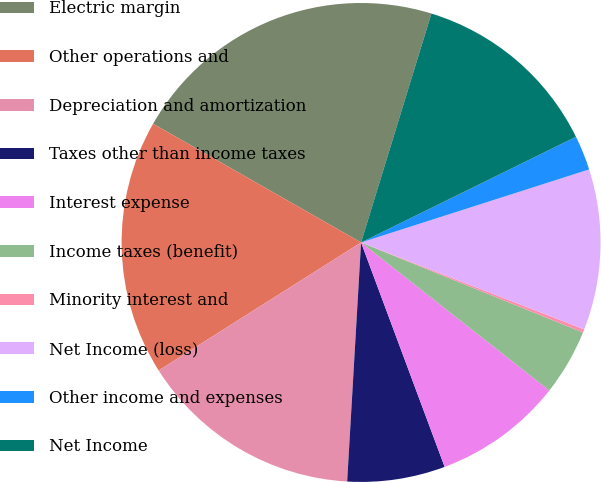Convert chart. <chart><loc_0><loc_0><loc_500><loc_500><pie_chart><fcel>Electric margin<fcel>Other operations and<fcel>Depreciation and amortization<fcel>Taxes other than income taxes<fcel>Interest expense<fcel>Income taxes (benefit)<fcel>Minority interest and<fcel>Net Income (loss)<fcel>Other income and expenses<fcel>Net Income<nl><fcel>21.49%<fcel>17.23%<fcel>15.1%<fcel>6.6%<fcel>8.72%<fcel>4.47%<fcel>0.22%<fcel>10.85%<fcel>2.34%<fcel>12.98%<nl></chart> 